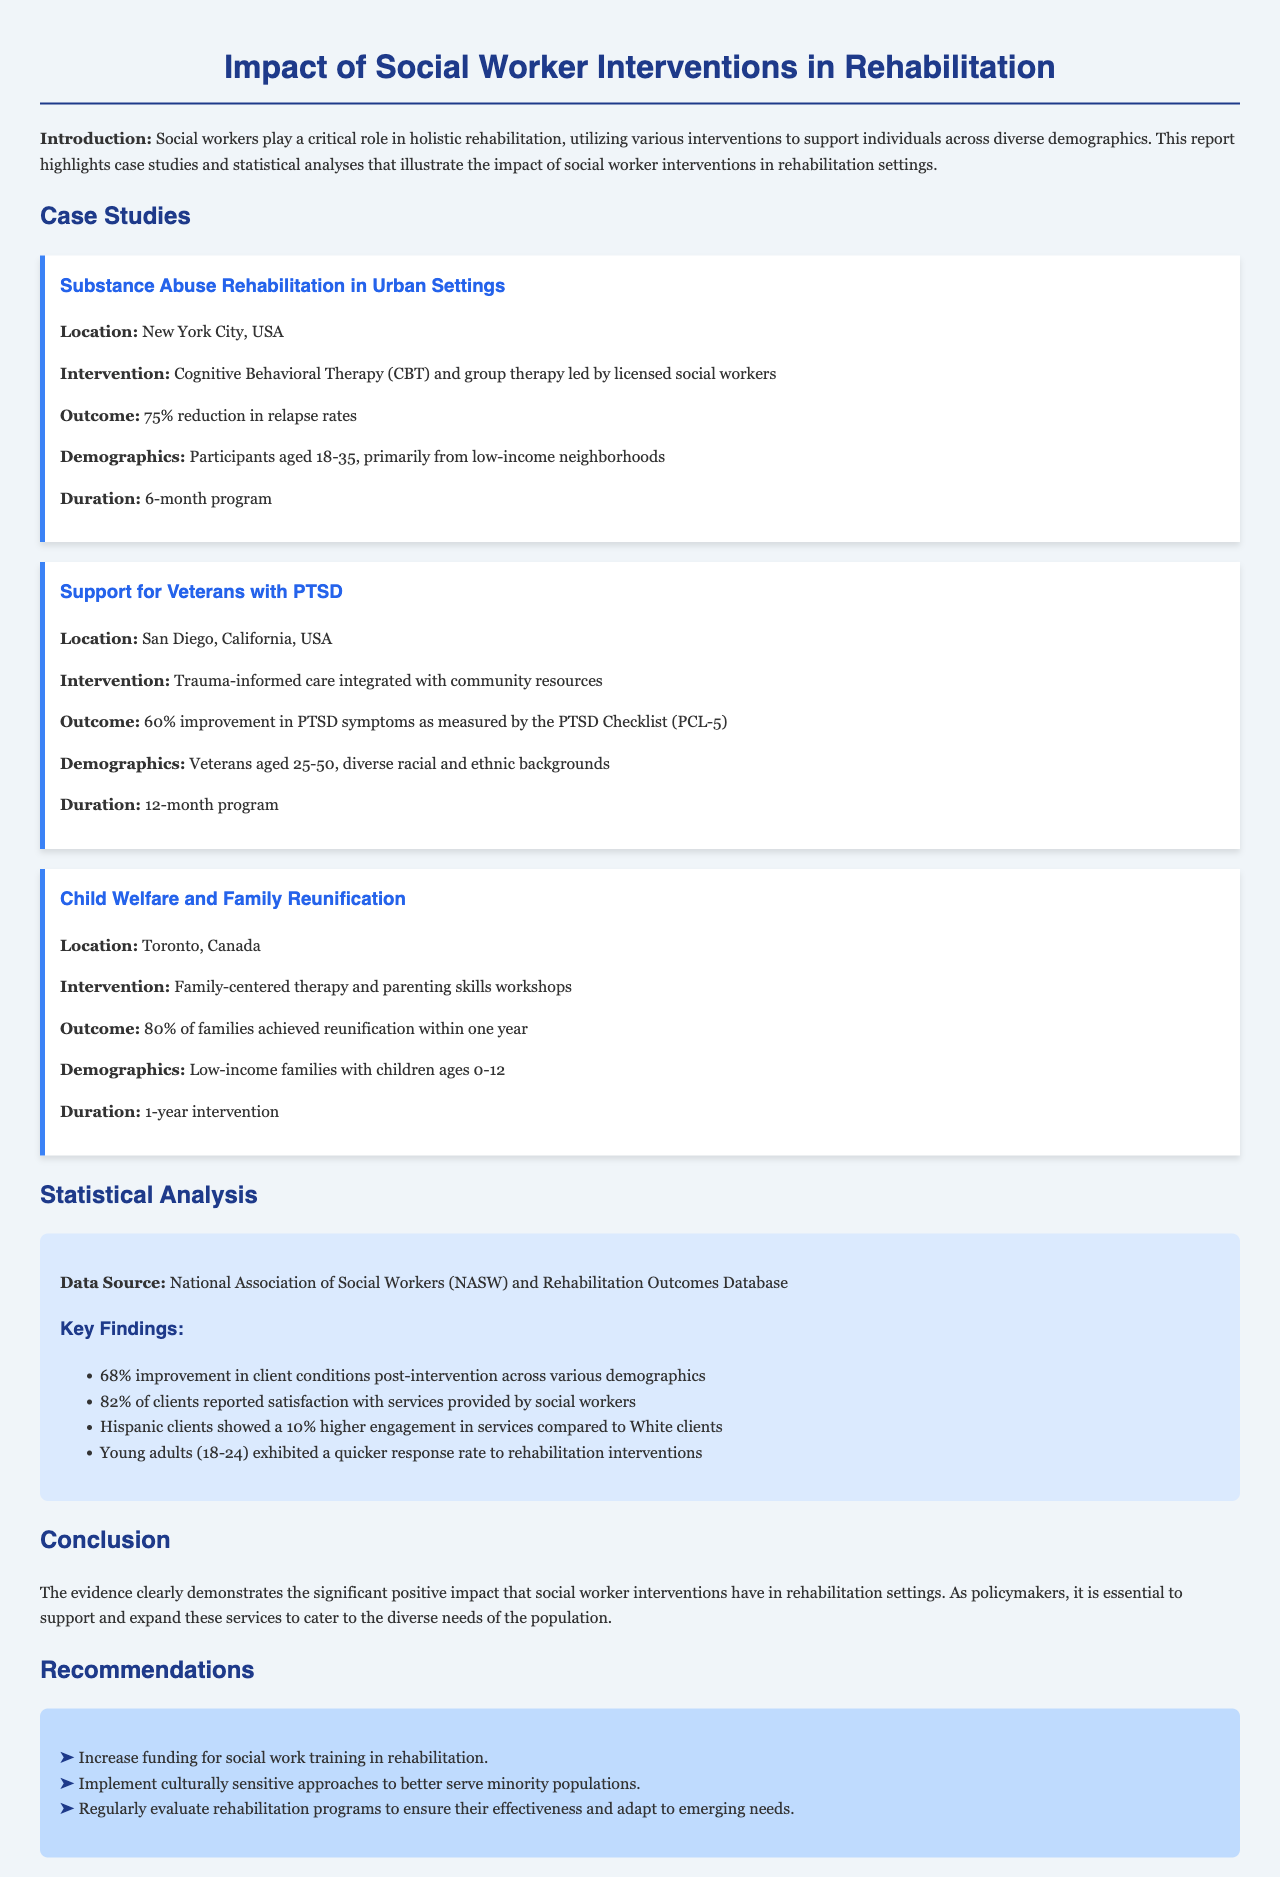What is the outcome of the substance abuse rehabilitation program? The outcome is a 75% reduction in relapse rates among participants.
Answer: 75% reduction in relapse rates What is the location of the study on veterans with PTSD? The study took place in San Diego, California, USA.
Answer: San Diego, California, USA What is the duration of the child welfare and family reunification intervention? The intervention lasted for one year, focusing on family reunification efforts.
Answer: 1-year intervention What percentage of clients reported satisfaction with social worker services? According to the report, 82% of clients expressed satisfaction with the services received.
Answer: 82% Which demographic group showed higher engagement in services compared to White clients? Hispanic clients engaged 10% more in social worker services than their White counterparts.
Answer: Hispanic clients What intervention was used in the substance abuse rehabilitation case? The intervention involved Cognitive Behavioral Therapy (CBT) and group therapy.
Answer: Cognitive Behavioral Therapy (CBT) and group therapy How many families achieved reunification within one year in the child welfare case study? The case study indicated that 80% of the families achieved reunification.
Answer: 80% What is the total improvement in client conditions post-intervention across various demographics? The report shows a 68% improvement in client conditions after interventions.
Answer: 68% What recommendation is made for social work training in rehabilitation? The report recommends increasing funding for social work training in rehabilitation settings.
Answer: Increase funding for social work training in rehabilitation 